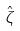Convert formula to latex. <formula><loc_0><loc_0><loc_500><loc_500>\hat { \zeta }</formula> 